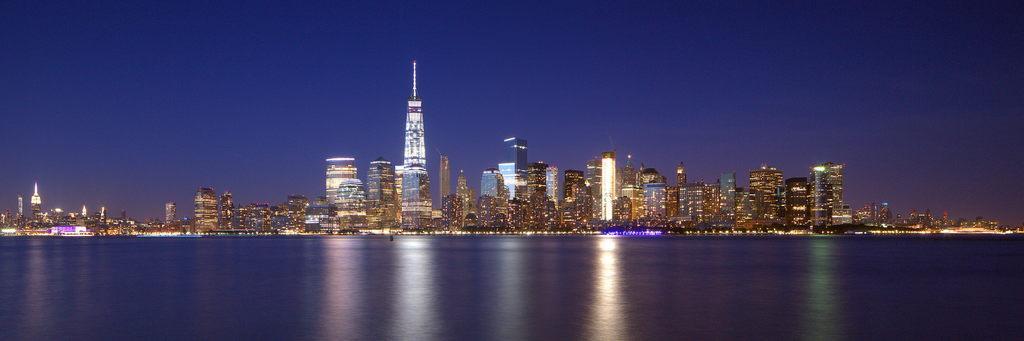How would you summarize this image in a sentence or two? In this image I can see the water, few buildings and few lights to the buildings. In the background I can see the sky. 